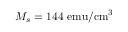<formula> <loc_0><loc_0><loc_500><loc_500>M _ { s } = 1 4 4 e m u / c m ^ { 3 }</formula> 